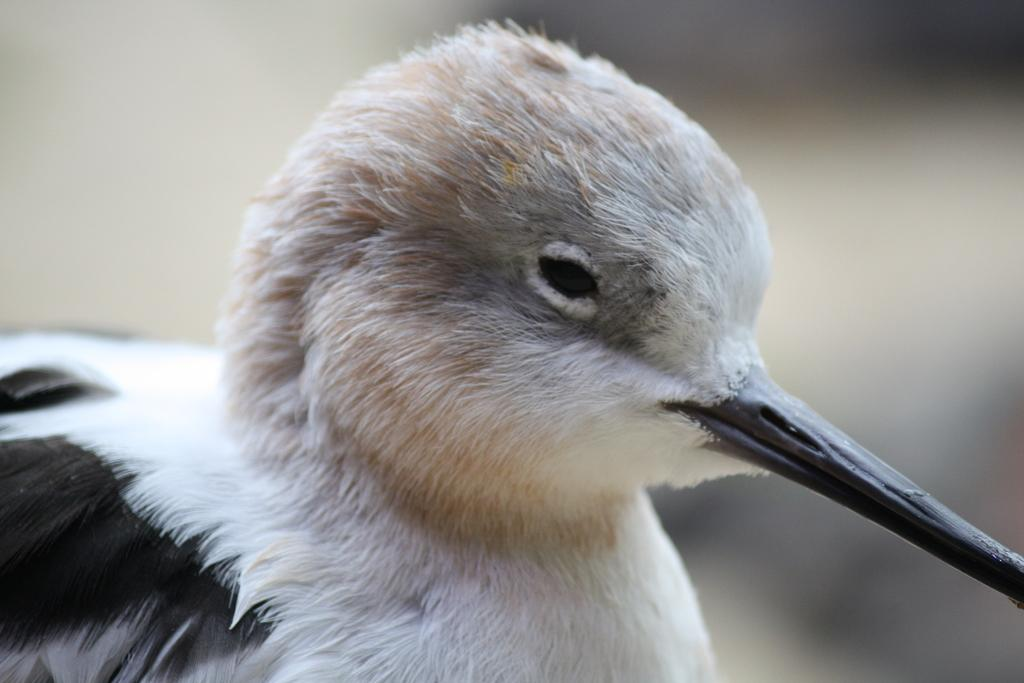What type of animal can be seen in the image? There is a bird in the image. Can you describe the background of the image? The background of the image is blurry. What decision does the bird make in the image? There is no indication of the bird making a decision in the image. What type of arm is visible in the image? There are no arms visible in the image; it features a bird and a blurry background. 